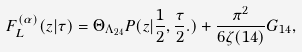<formula> <loc_0><loc_0><loc_500><loc_500>F _ { L } ^ { ( \alpha ) } ( z | \tau ) = \Theta _ { \Lambda _ { 2 4 } } P ( z | \frac { 1 } { 2 } , \frac { \tau } { 2 } . ) + \frac { \pi ^ { 2 } } { 6 \zeta ( 1 4 ) } G _ { 1 4 } ,</formula> 